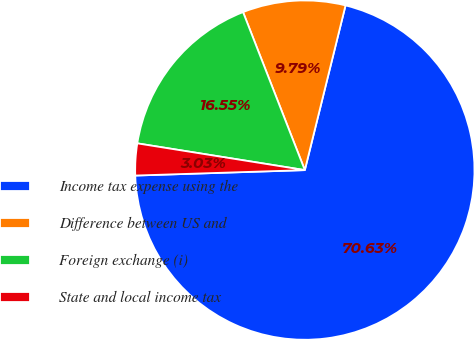Convert chart. <chart><loc_0><loc_0><loc_500><loc_500><pie_chart><fcel>Income tax expense using the<fcel>Difference between US and<fcel>Foreign exchange (i)<fcel>State and local income tax<nl><fcel>70.64%<fcel>9.79%<fcel>16.55%<fcel>3.03%<nl></chart> 